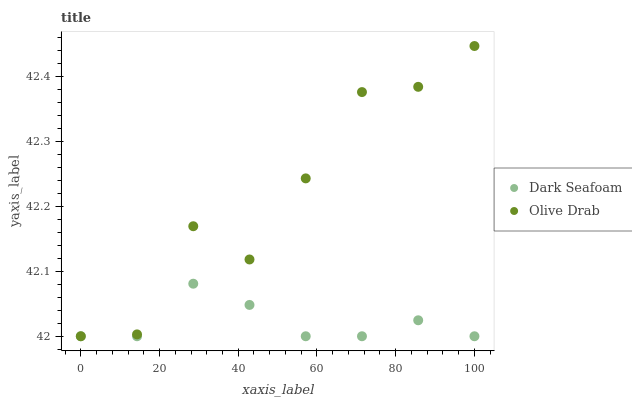Does Dark Seafoam have the minimum area under the curve?
Answer yes or no. Yes. Does Olive Drab have the maximum area under the curve?
Answer yes or no. Yes. Does Olive Drab have the minimum area under the curve?
Answer yes or no. No. Is Dark Seafoam the smoothest?
Answer yes or no. Yes. Is Olive Drab the roughest?
Answer yes or no. Yes. Is Olive Drab the smoothest?
Answer yes or no. No. Does Dark Seafoam have the lowest value?
Answer yes or no. Yes. Does Olive Drab have the highest value?
Answer yes or no. Yes. Does Olive Drab intersect Dark Seafoam?
Answer yes or no. Yes. Is Olive Drab less than Dark Seafoam?
Answer yes or no. No. Is Olive Drab greater than Dark Seafoam?
Answer yes or no. No. 